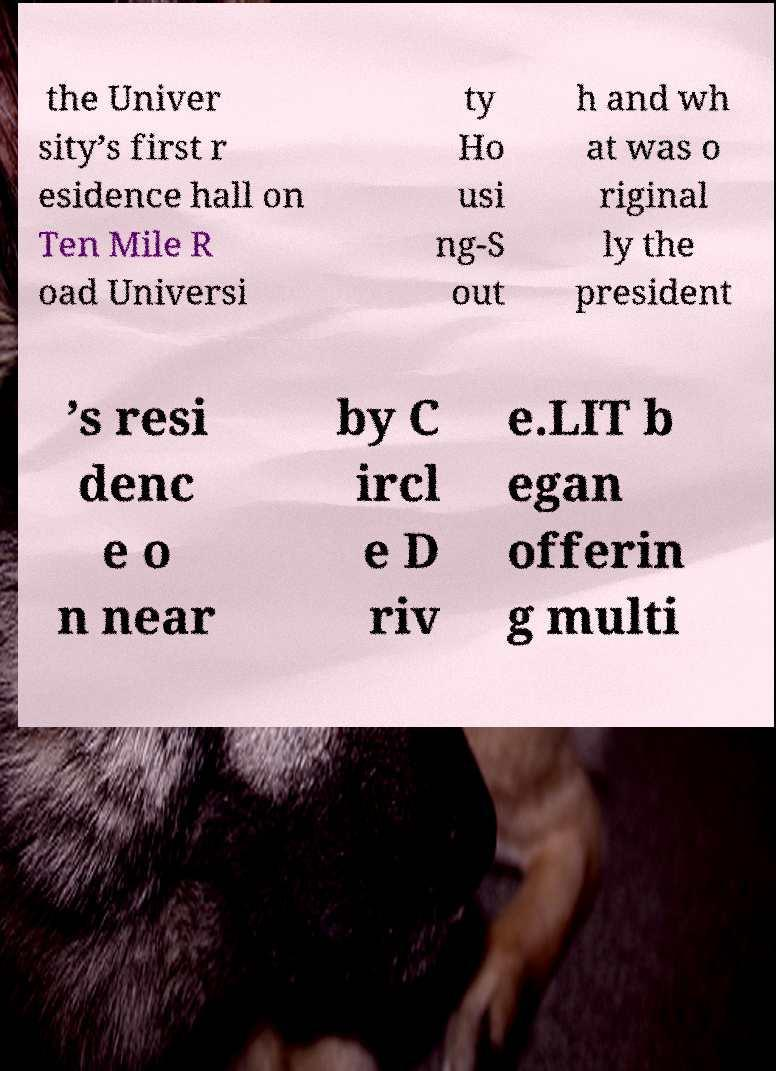For documentation purposes, I need the text within this image transcribed. Could you provide that? the Univer sity’s first r esidence hall on Ten Mile R oad Universi ty Ho usi ng-S out h and wh at was o riginal ly the president ’s resi denc e o n near by C ircl e D riv e.LIT b egan offerin g multi 